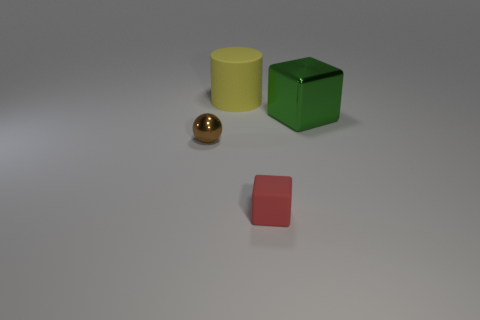What is the color of the big object behind the block that is on the right side of the rubber thing in front of the large metallic object?
Provide a short and direct response. Yellow. What number of other things are the same material as the red cube?
Your response must be concise. 1. Do the thing left of the yellow cylinder and the green object have the same shape?
Your response must be concise. No. How many big objects are gray rubber cubes or red rubber things?
Give a very brief answer. 0. Is the number of big objects that are behind the large yellow thing the same as the number of metal blocks that are on the right side of the tiny brown object?
Your answer should be very brief. No. How many blue objects are large cylinders or spheres?
Give a very brief answer. 0. Are there the same number of small metal objects behind the tiny brown object and cyan rubber objects?
Make the answer very short. Yes. What color is the other object that is the same shape as the small matte thing?
Your response must be concise. Green. How many other things are the same shape as the tiny red matte object?
Give a very brief answer. 1. What number of big blue matte balls are there?
Provide a succinct answer. 0. 